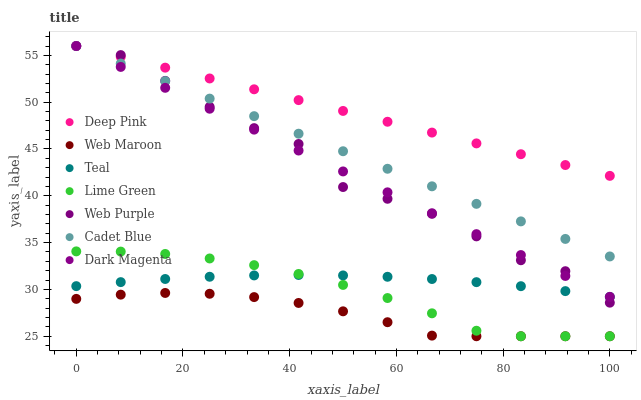Does Web Maroon have the minimum area under the curve?
Answer yes or no. Yes. Does Deep Pink have the maximum area under the curve?
Answer yes or no. Yes. Does Dark Magenta have the minimum area under the curve?
Answer yes or no. No. Does Dark Magenta have the maximum area under the curve?
Answer yes or no. No. Is Cadet Blue the smoothest?
Answer yes or no. Yes. Is Web Purple the roughest?
Answer yes or no. Yes. Is Dark Magenta the smoothest?
Answer yes or no. No. Is Dark Magenta the roughest?
Answer yes or no. No. Does Web Maroon have the lowest value?
Answer yes or no. Yes. Does Dark Magenta have the lowest value?
Answer yes or no. No. Does Deep Pink have the highest value?
Answer yes or no. Yes. Does Web Maroon have the highest value?
Answer yes or no. No. Is Teal less than Cadet Blue?
Answer yes or no. Yes. Is Web Purple greater than Lime Green?
Answer yes or no. Yes. Does Lime Green intersect Teal?
Answer yes or no. Yes. Is Lime Green less than Teal?
Answer yes or no. No. Is Lime Green greater than Teal?
Answer yes or no. No. Does Teal intersect Cadet Blue?
Answer yes or no. No. 